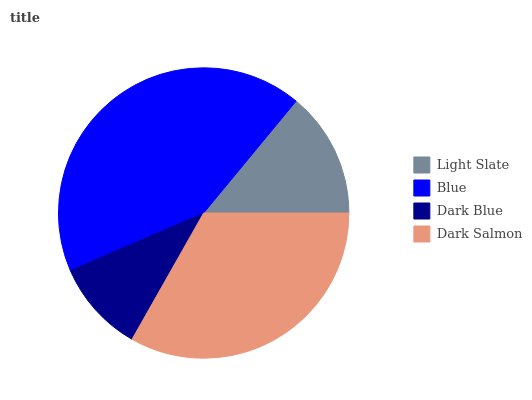Is Dark Blue the minimum?
Answer yes or no. Yes. Is Blue the maximum?
Answer yes or no. Yes. Is Blue the minimum?
Answer yes or no. No. Is Dark Blue the maximum?
Answer yes or no. No. Is Blue greater than Dark Blue?
Answer yes or no. Yes. Is Dark Blue less than Blue?
Answer yes or no. Yes. Is Dark Blue greater than Blue?
Answer yes or no. No. Is Blue less than Dark Blue?
Answer yes or no. No. Is Dark Salmon the high median?
Answer yes or no. Yes. Is Light Slate the low median?
Answer yes or no. Yes. Is Dark Blue the high median?
Answer yes or no. No. Is Dark Salmon the low median?
Answer yes or no. No. 